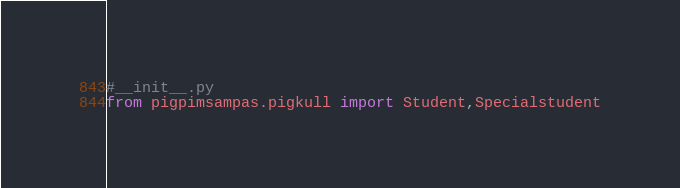<code> <loc_0><loc_0><loc_500><loc_500><_Python_>#__init__.py
from pigpimsampas.pigkull import Student,Specialstudent</code> 